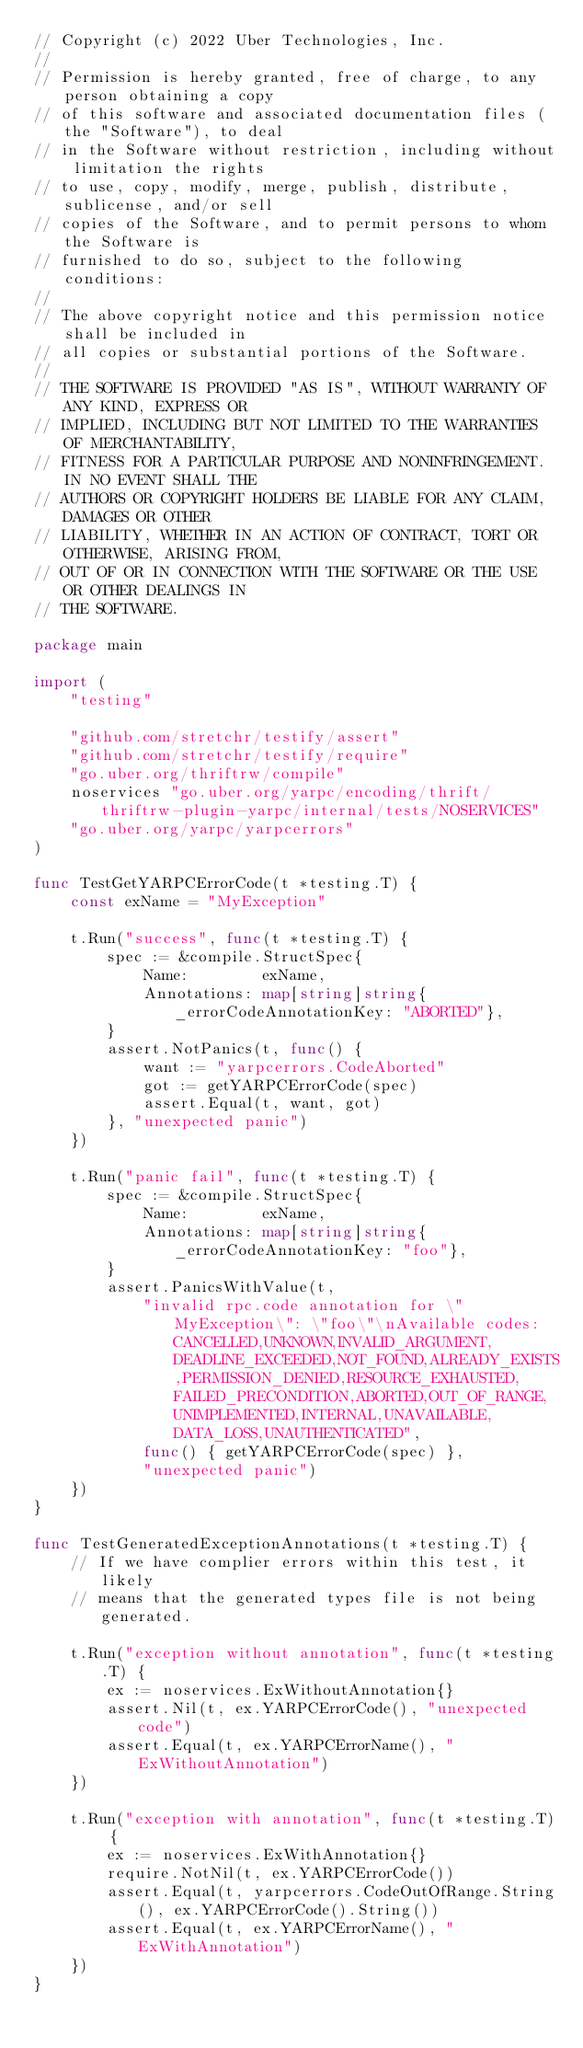<code> <loc_0><loc_0><loc_500><loc_500><_Go_>// Copyright (c) 2022 Uber Technologies, Inc.
//
// Permission is hereby granted, free of charge, to any person obtaining a copy
// of this software and associated documentation files (the "Software"), to deal
// in the Software without restriction, including without limitation the rights
// to use, copy, modify, merge, publish, distribute, sublicense, and/or sell
// copies of the Software, and to permit persons to whom the Software is
// furnished to do so, subject to the following conditions:
//
// The above copyright notice and this permission notice shall be included in
// all copies or substantial portions of the Software.
//
// THE SOFTWARE IS PROVIDED "AS IS", WITHOUT WARRANTY OF ANY KIND, EXPRESS OR
// IMPLIED, INCLUDING BUT NOT LIMITED TO THE WARRANTIES OF MERCHANTABILITY,
// FITNESS FOR A PARTICULAR PURPOSE AND NONINFRINGEMENT. IN NO EVENT SHALL THE
// AUTHORS OR COPYRIGHT HOLDERS BE LIABLE FOR ANY CLAIM, DAMAGES OR OTHER
// LIABILITY, WHETHER IN AN ACTION OF CONTRACT, TORT OR OTHERWISE, ARISING FROM,
// OUT OF OR IN CONNECTION WITH THE SOFTWARE OR THE USE OR OTHER DEALINGS IN
// THE SOFTWARE.

package main

import (
	"testing"

	"github.com/stretchr/testify/assert"
	"github.com/stretchr/testify/require"
	"go.uber.org/thriftrw/compile"
	noservices "go.uber.org/yarpc/encoding/thrift/thriftrw-plugin-yarpc/internal/tests/NOSERVICES"
	"go.uber.org/yarpc/yarpcerrors"
)

func TestGetYARPCErrorCode(t *testing.T) {
	const exName = "MyException"

	t.Run("success", func(t *testing.T) {
		spec := &compile.StructSpec{
			Name:        exName,
			Annotations: map[string]string{_errorCodeAnnotationKey: "ABORTED"},
		}
		assert.NotPanics(t, func() {
			want := "yarpcerrors.CodeAborted"
			got := getYARPCErrorCode(spec)
			assert.Equal(t, want, got)
		}, "unexpected panic")
	})

	t.Run("panic fail", func(t *testing.T) {
		spec := &compile.StructSpec{
			Name:        exName,
			Annotations: map[string]string{_errorCodeAnnotationKey: "foo"},
		}
		assert.PanicsWithValue(t,
			"invalid rpc.code annotation for \"MyException\": \"foo\"\nAvailable codes: CANCELLED,UNKNOWN,INVALID_ARGUMENT,DEADLINE_EXCEEDED,NOT_FOUND,ALREADY_EXISTS,PERMISSION_DENIED,RESOURCE_EXHAUSTED,FAILED_PRECONDITION,ABORTED,OUT_OF_RANGE,UNIMPLEMENTED,INTERNAL,UNAVAILABLE,DATA_LOSS,UNAUTHENTICATED",
			func() { getYARPCErrorCode(spec) },
			"unexpected panic")
	})
}

func TestGeneratedExceptionAnnotations(t *testing.T) {
	// If we have complier errors within this test, it likely
	// means that the generated types file is not being generated.

	t.Run("exception without annotation", func(t *testing.T) {
		ex := noservices.ExWithoutAnnotation{}
		assert.Nil(t, ex.YARPCErrorCode(), "unexpected code")
		assert.Equal(t, ex.YARPCErrorName(), "ExWithoutAnnotation")
	})

	t.Run("exception with annotation", func(t *testing.T) {
		ex := noservices.ExWithAnnotation{}
		require.NotNil(t, ex.YARPCErrorCode())
		assert.Equal(t, yarpcerrors.CodeOutOfRange.String(), ex.YARPCErrorCode().String())
		assert.Equal(t, ex.YARPCErrorName(), "ExWithAnnotation")
	})
}
</code> 